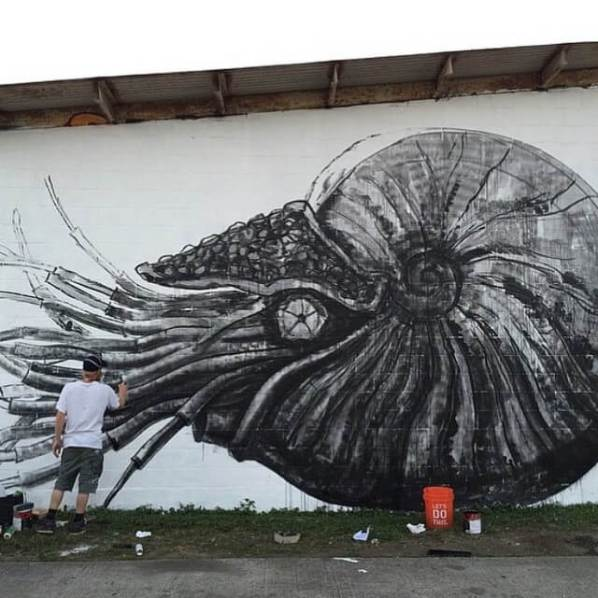How did the muralist achieve the fine textures and details evident in the mural? The fine textures and details in the mural were likely achieved through a combination of techniques and tools. The use of multiple paint cans indicates the application of various shades and tones, allowing the artist to create depth and contrast. Brushes of different sizes and types would have been used for detailed work, while a roller could have been employed for broader strokes. Layering the paint, possibly starting with a base layer and gradually adding finer details, helps in creating a rich and detailed texture. The artist's meticulous approach, evidenced by the array of tools and supplies, highlights their dedication to achieving a highly detailed and textured mural. What challenges might the muralist have faced while painting such a large piece? Painting a mural of this size likely presented several challenges for the artist. One notable challenge is maintaining the proportions and continuity of the artwork across a large surface. This requires careful planning and perhaps even preliminary sketches or grids to ensure consistency. Another challenge is the physical demand of painting on such a large scale, which can include prolonged periods of standing, reaching, or climbing to reach higher sections. Weather conditions can also impact the painting process, as outdoor murals are subject to rain, wind, and varying temperatures that can affect the paint's drying time and adherence to the wall. Logistics, such as ensuring an adequate supply of paints and tools, and managing these materials efficiently, are also critical. Despite these challenges, the muralist's preparation and the final outcome suggest a skilled and disciplined approach to mural painting. 